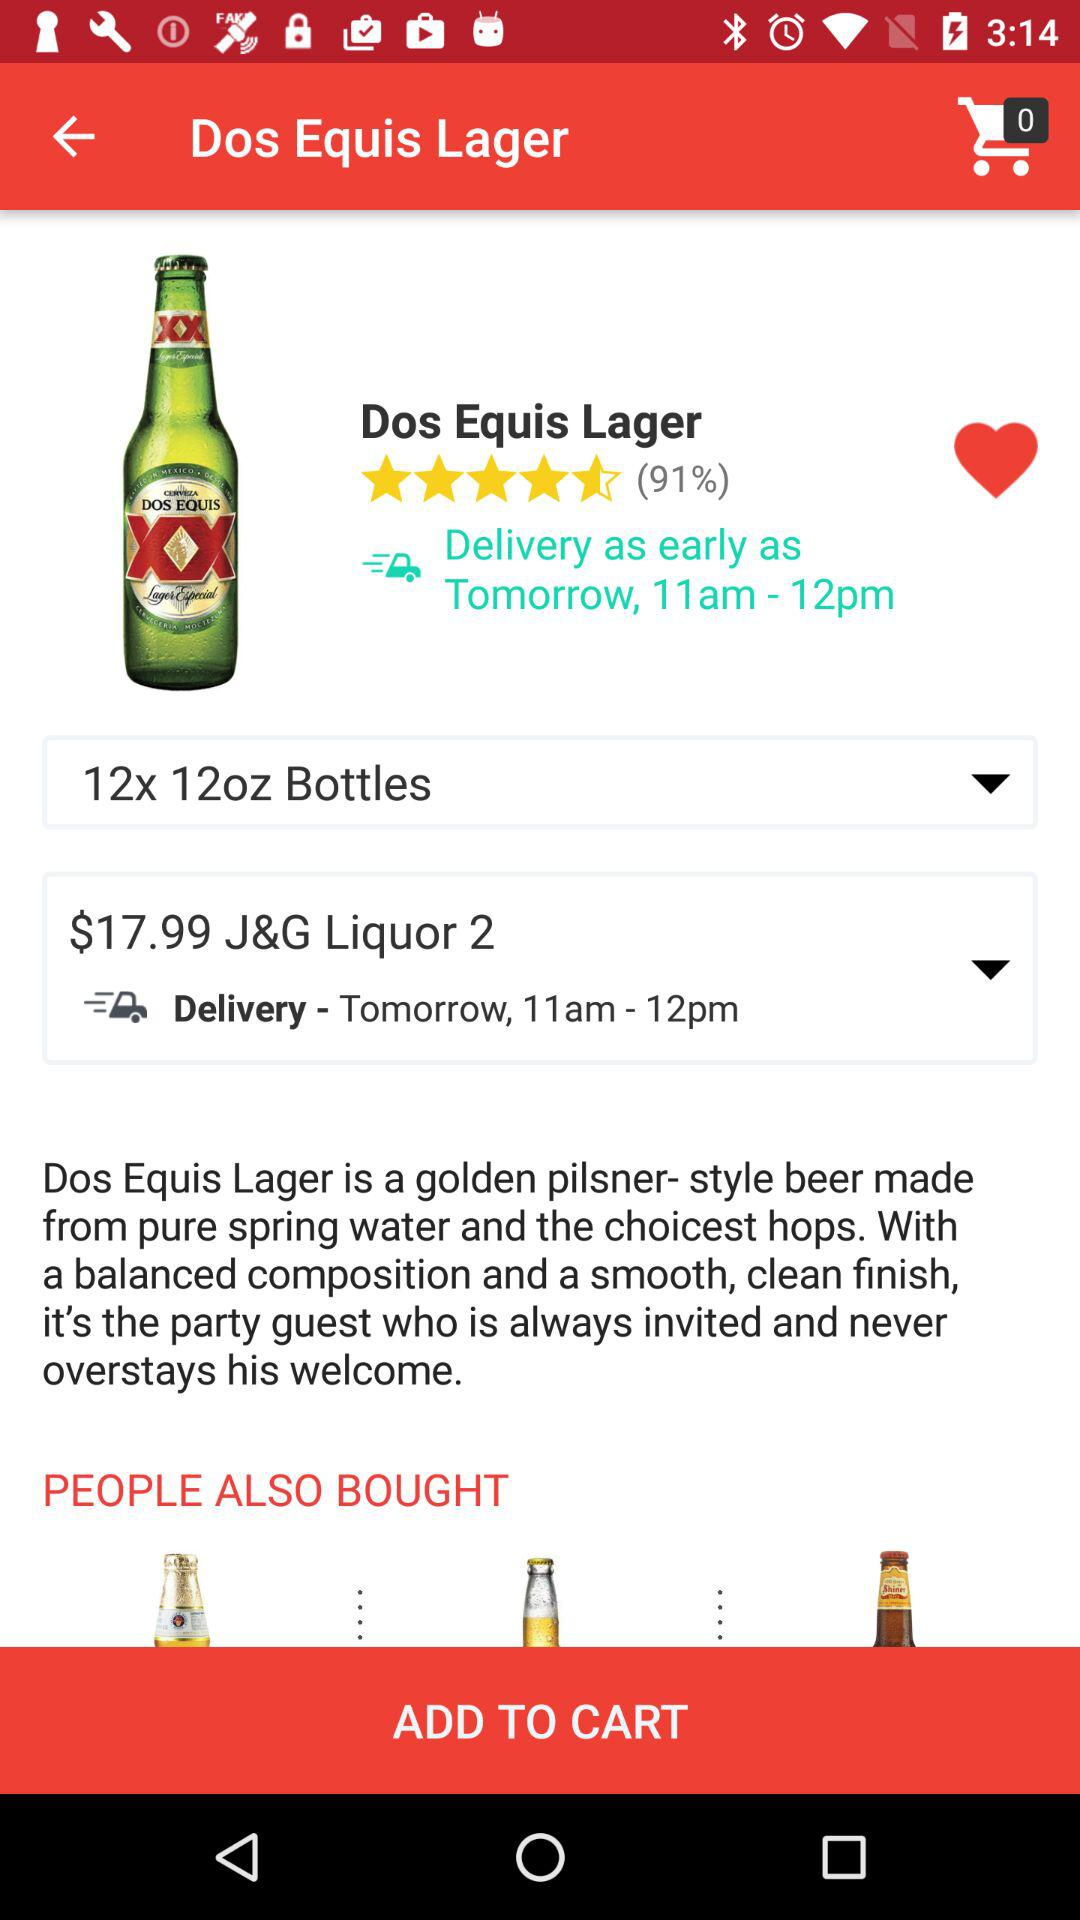How many items are in the shopping cart? There are 0 items in the shopping cart. 